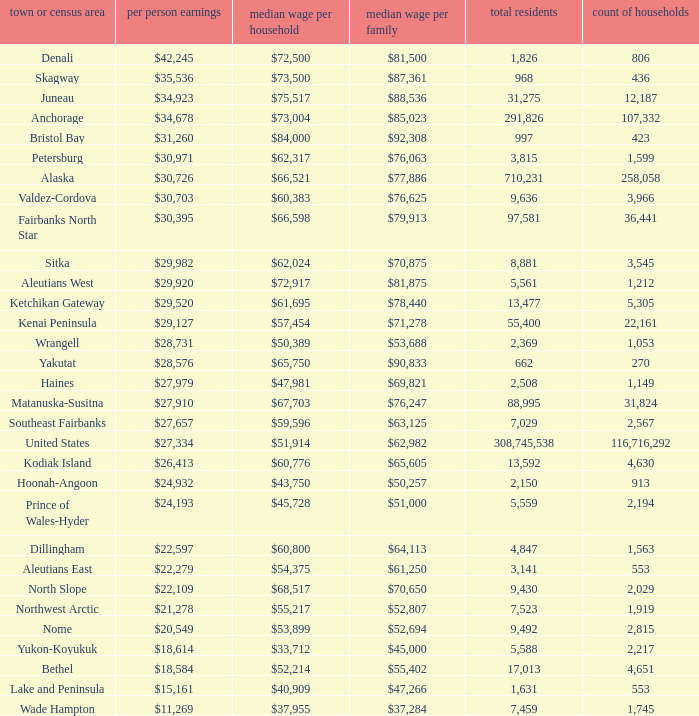Which borough or census area has a $59,596 median household income? Southeast Fairbanks. 